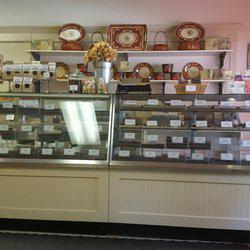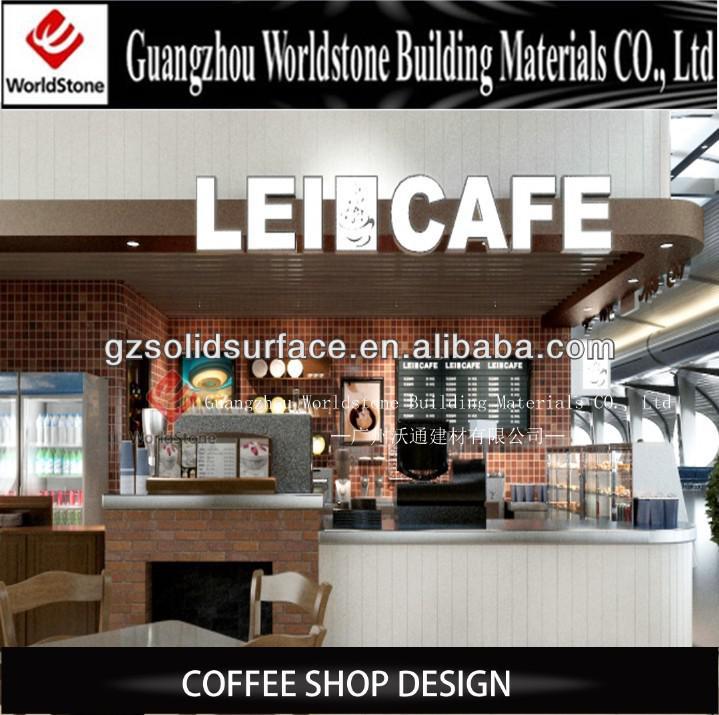The first image is the image on the left, the second image is the image on the right. Given the left and right images, does the statement "One image shows a small seating area for customers." hold true? Answer yes or no. Yes. The first image is the image on the left, the second image is the image on the right. Analyze the images presented: Is the assertion "There are hanging lights above the counter in one of the images." valid? Answer yes or no. No. 